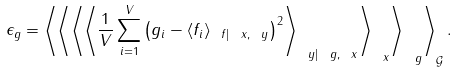<formula> <loc_0><loc_0><loc_500><loc_500>\epsilon _ { g } = \left \langle \left \langle \left \langle \left \langle \frac { 1 } { V } \sum _ { i = 1 } ^ { V } \left ( g _ { i } - \langle f _ { i } \rangle _ { \ f | \ x , \ y } \right ) ^ { 2 } \right \rangle _ { \ y | \ g , \ x } \right \rangle _ { \ x } \right \rangle _ { \ g } \right \rangle _ { \mathcal { G } } .</formula> 